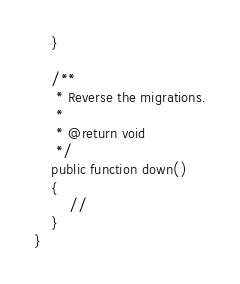<code> <loc_0><loc_0><loc_500><loc_500><_PHP_>    }

    /**
     * Reverse the migrations.
     *
     * @return void
     */
    public function down()
    {
        //
    }
}
</code> 